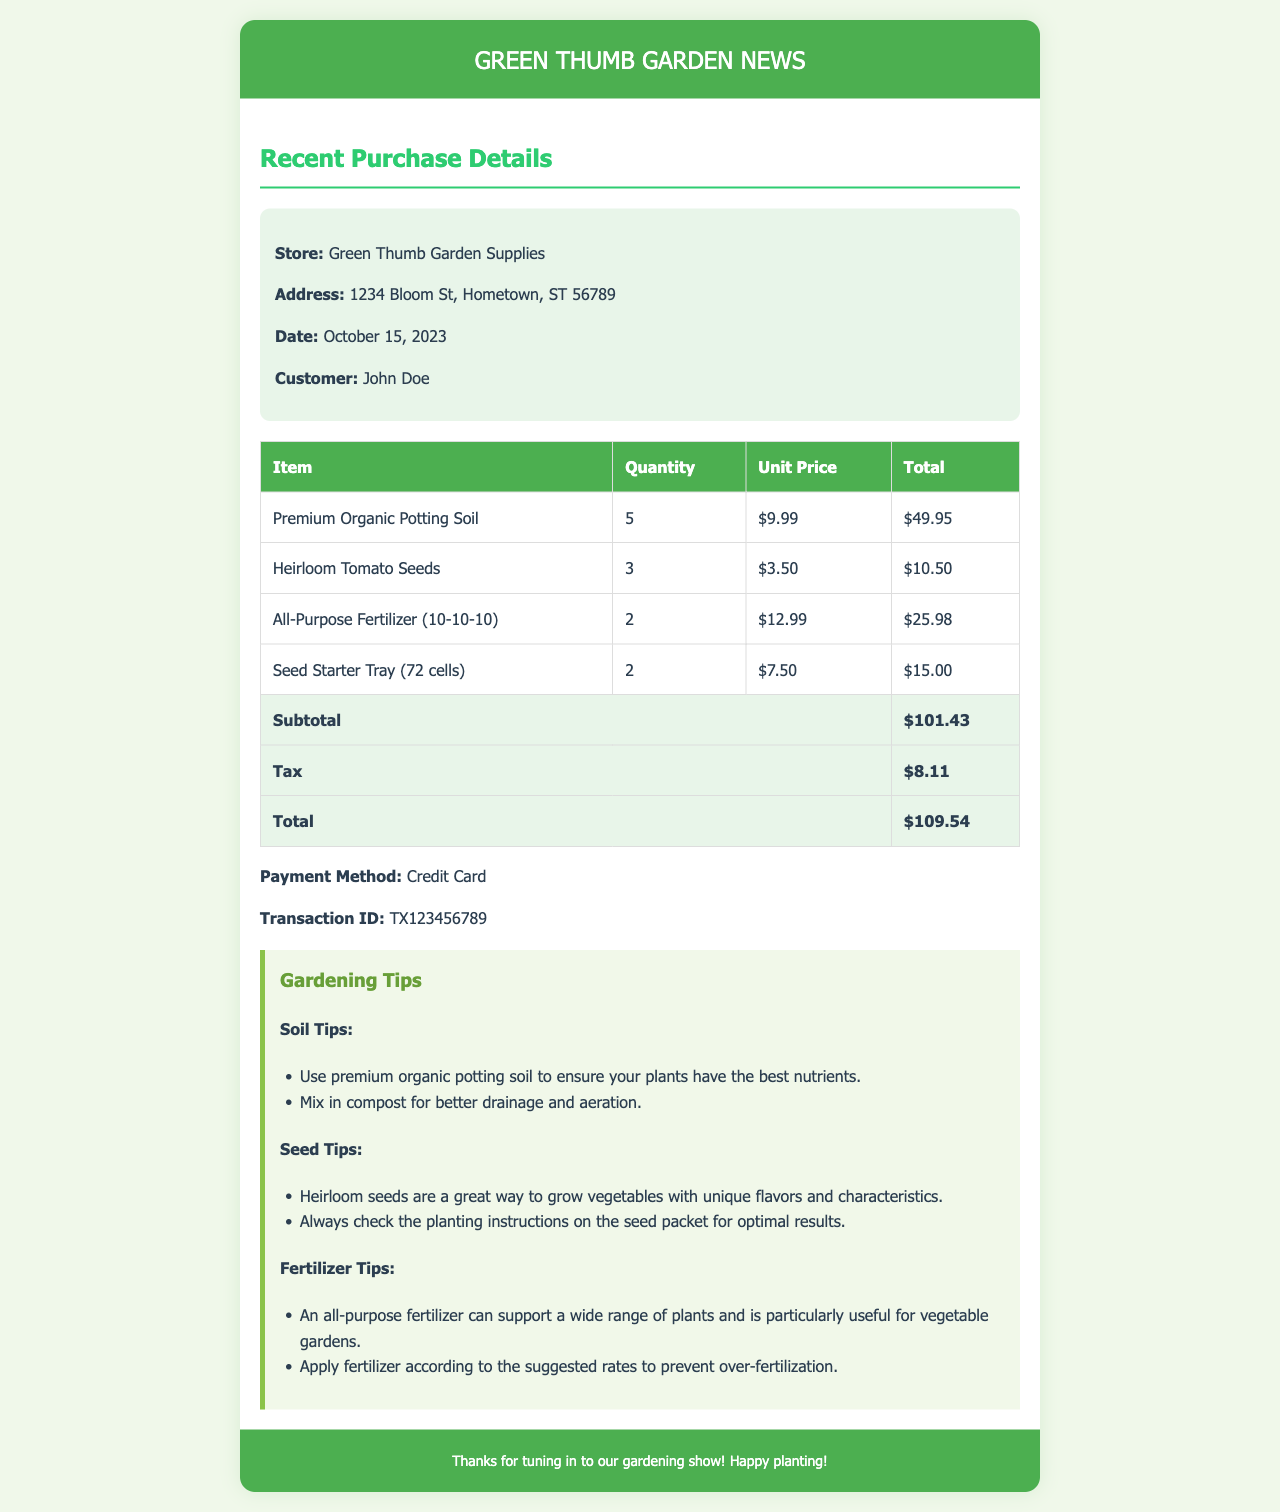What is the store name? The store name is listed in the document header as the location from which the purchases were made.
Answer: Green Thumb Garden Supplies What is the purchase date? The purchase date is specified prominently in the invoice details section of the document.
Answer: October 15, 2023 How many units of Premium Organic Potting Soil were purchased? This information can be found in the invoice table detailing the items and their quantities.
Answer: 5 What is the total amount before tax? The subtotal before tax is clearly stated in the invoice's total section.
Answer: $101.43 What method of payment was used? The payment method is indicated in the invoice details, outlining how the transaction was completed.
Answer: Credit Card What is the transaction ID? This unique identifier for the payment is included in the invoice details for reference.
Answer: TX123456789 Which fertilizer type was purchased? The invoice table lists the specific fertilizer purchased, along with details about quantity and price.
Answer: All-Purpose Fertilizer (10-10-10) How many different types of seeds were bought? This can be deduced from the invoice table showing the types of seeds listed.
Answer: 1 What gardening tip is related to heirloom seeds? The document provides advice on heirloom seeds in the tips section, including their benefits.
Answer: Unique flavors and characteristics 